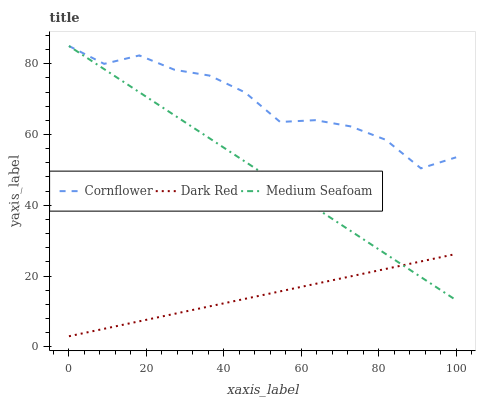Does Medium Seafoam have the minimum area under the curve?
Answer yes or no. No. Does Medium Seafoam have the maximum area under the curve?
Answer yes or no. No. Is Medium Seafoam the smoothest?
Answer yes or no. No. Is Medium Seafoam the roughest?
Answer yes or no. No. Does Medium Seafoam have the lowest value?
Answer yes or no. No. Does Dark Red have the highest value?
Answer yes or no. No. Is Dark Red less than Cornflower?
Answer yes or no. Yes. Is Cornflower greater than Dark Red?
Answer yes or no. Yes. Does Dark Red intersect Cornflower?
Answer yes or no. No. 